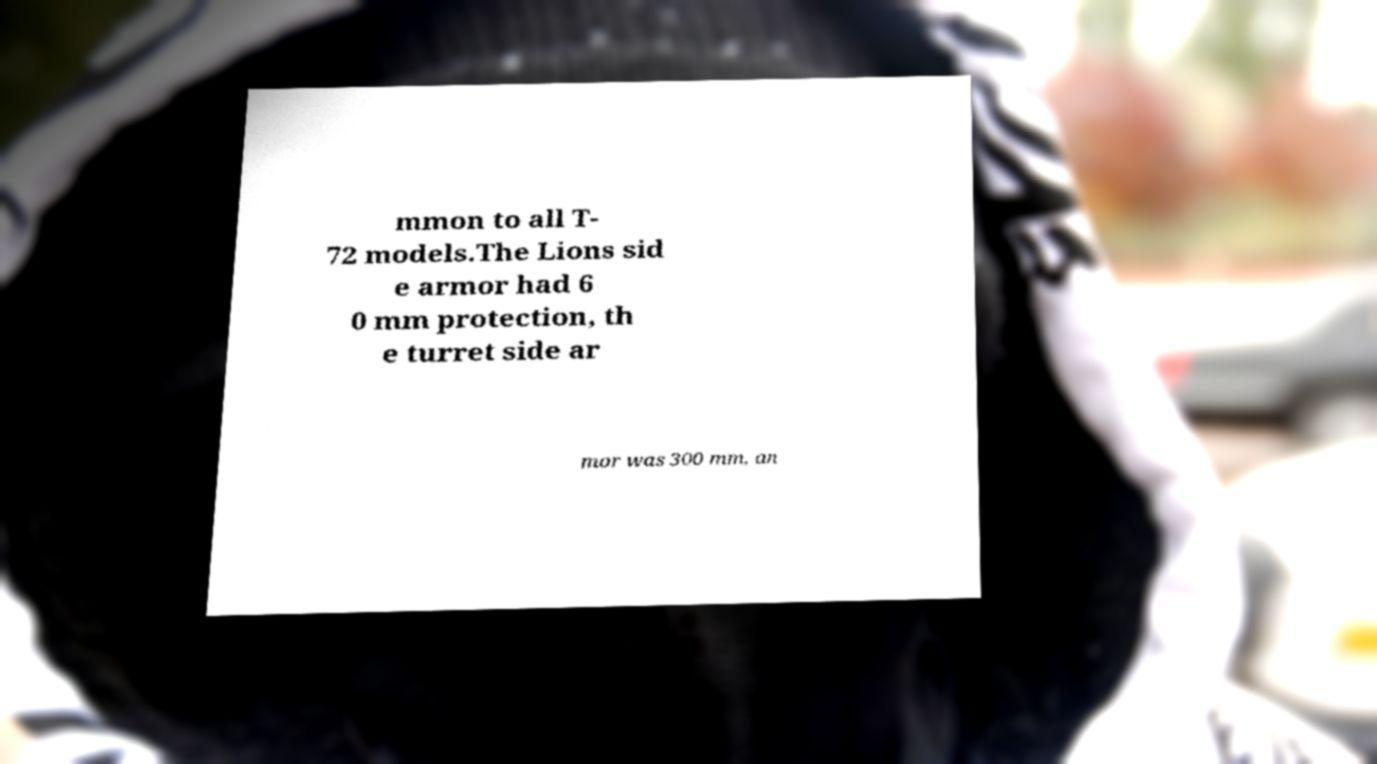Could you extract and type out the text from this image? mmon to all T- 72 models.The Lions sid e armor had 6 0 mm protection, th e turret side ar mor was 300 mm, an 